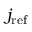Convert formula to latex. <formula><loc_0><loc_0><loc_500><loc_500>j _ { r e f }</formula> 